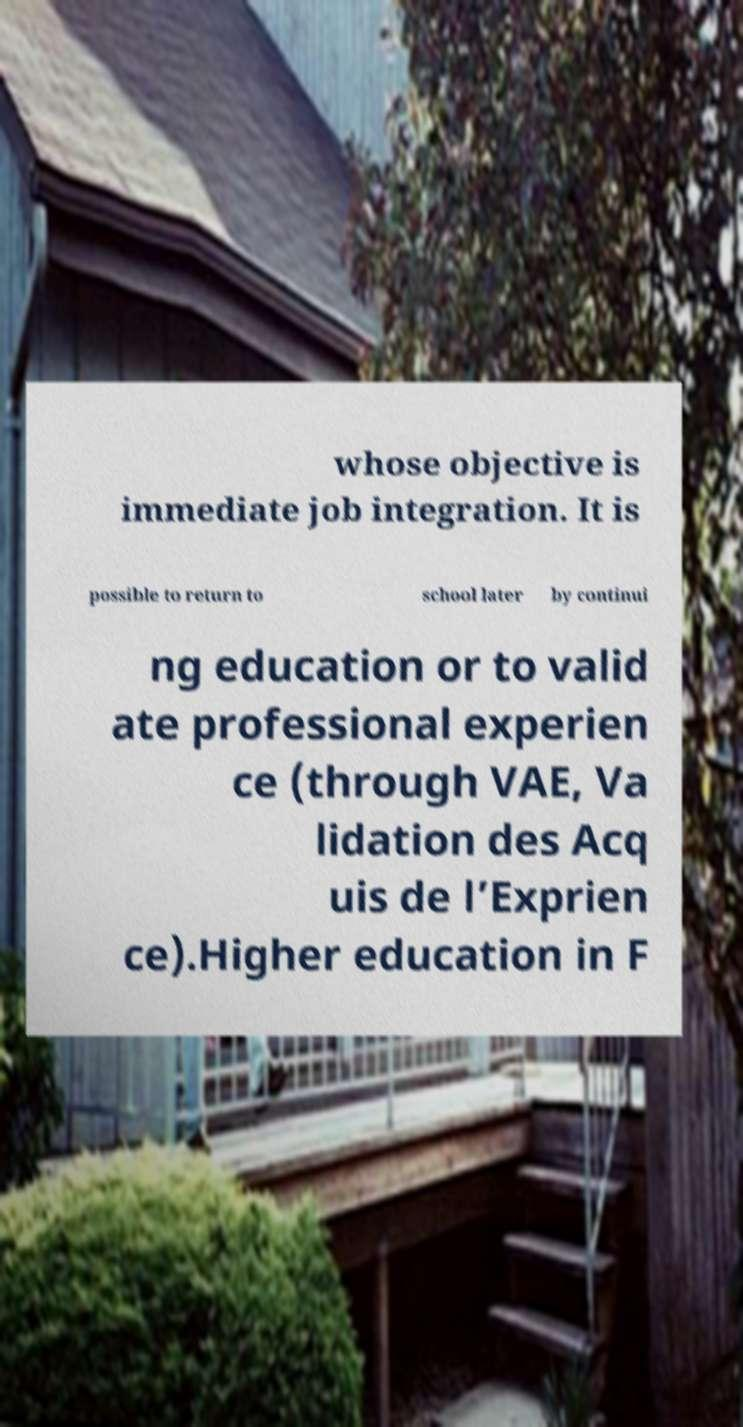What messages or text are displayed in this image? I need them in a readable, typed format. whose objective is immediate job integration. It is possible to return to school later by continui ng education or to valid ate professional experien ce (through VAE, Va lidation des Acq uis de l’Exprien ce).Higher education in F 